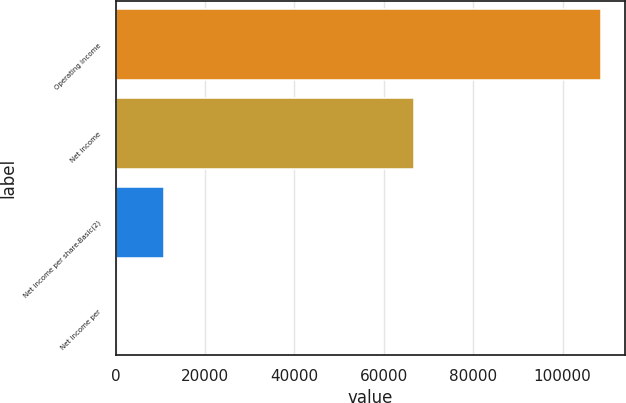Convert chart. <chart><loc_0><loc_0><loc_500><loc_500><bar_chart><fcel>Operating income<fcel>Net income<fcel>Net income per share-Basic(2)<fcel>Net income per<nl><fcel>108557<fcel>66699<fcel>10856<fcel>0.36<nl></chart> 